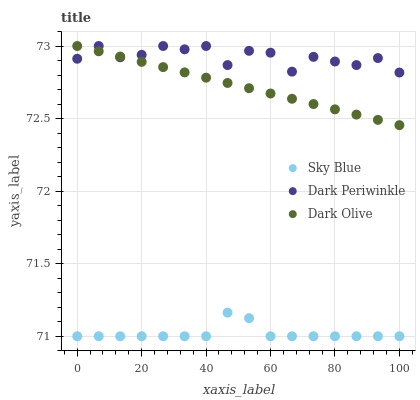Does Sky Blue have the minimum area under the curve?
Answer yes or no. Yes. Does Dark Periwinkle have the maximum area under the curve?
Answer yes or no. Yes. Does Dark Olive have the minimum area under the curve?
Answer yes or no. No. Does Dark Olive have the maximum area under the curve?
Answer yes or no. No. Is Dark Olive the smoothest?
Answer yes or no. Yes. Is Dark Periwinkle the roughest?
Answer yes or no. Yes. Is Dark Periwinkle the smoothest?
Answer yes or no. No. Is Dark Olive the roughest?
Answer yes or no. No. Does Sky Blue have the lowest value?
Answer yes or no. Yes. Does Dark Olive have the lowest value?
Answer yes or no. No. Does Dark Periwinkle have the highest value?
Answer yes or no. Yes. Is Sky Blue less than Dark Periwinkle?
Answer yes or no. Yes. Is Dark Olive greater than Sky Blue?
Answer yes or no. Yes. Does Dark Olive intersect Dark Periwinkle?
Answer yes or no. Yes. Is Dark Olive less than Dark Periwinkle?
Answer yes or no. No. Is Dark Olive greater than Dark Periwinkle?
Answer yes or no. No. Does Sky Blue intersect Dark Periwinkle?
Answer yes or no. No. 